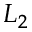<formula> <loc_0><loc_0><loc_500><loc_500>L _ { 2 }</formula> 